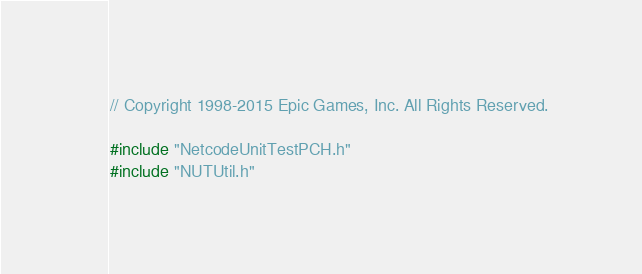<code> <loc_0><loc_0><loc_500><loc_500><_C++_>// Copyright 1998-2015 Epic Games, Inc. All Rights Reserved.

#include "NetcodeUnitTestPCH.h"
#include "NUTUtil.h"</code> 